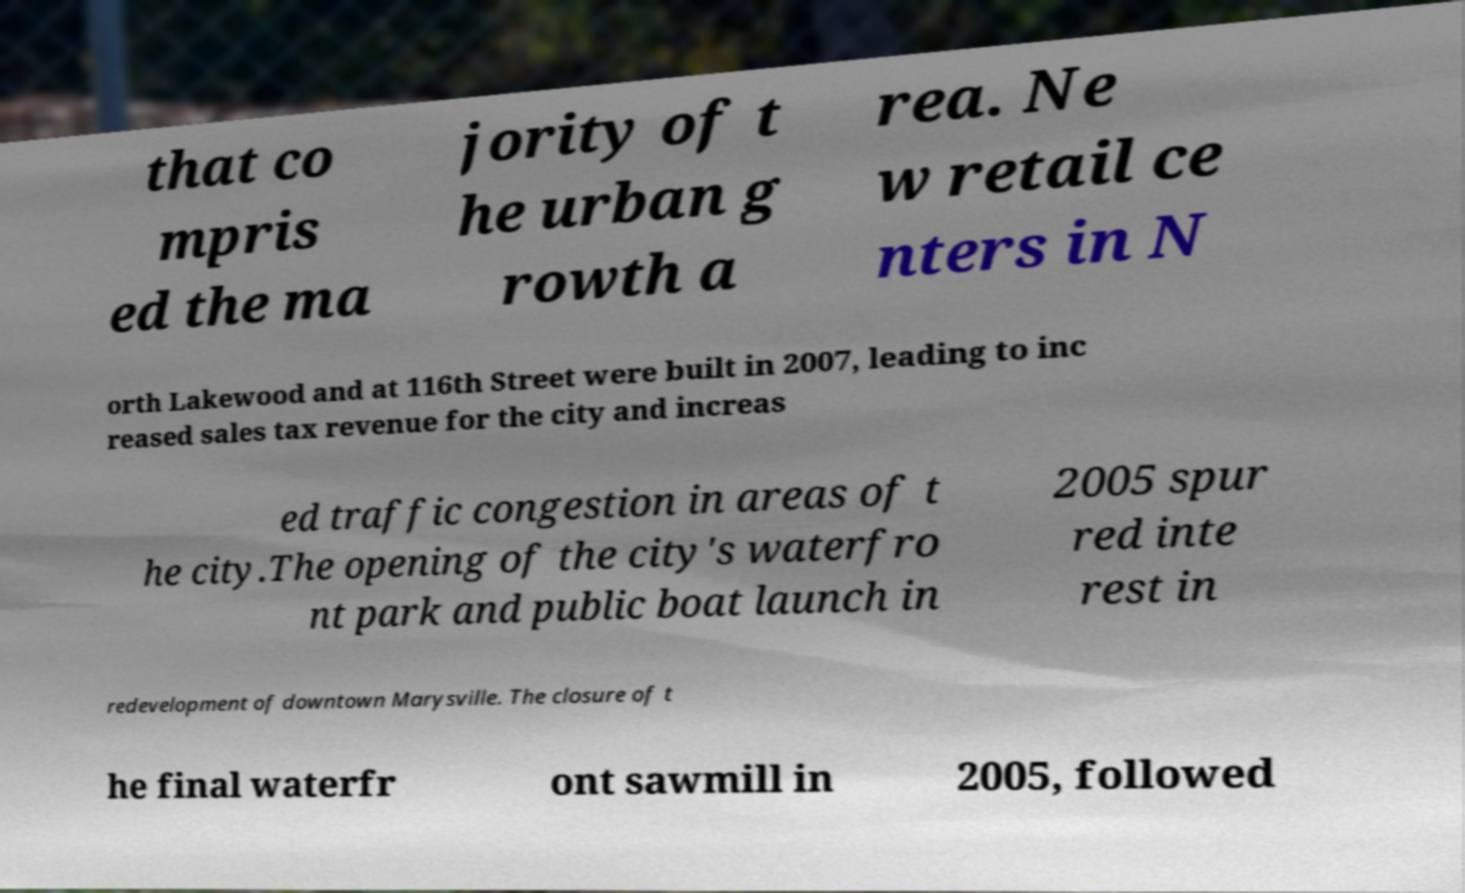What messages or text are displayed in this image? I need them in a readable, typed format. that co mpris ed the ma jority of t he urban g rowth a rea. Ne w retail ce nters in N orth Lakewood and at 116th Street were built in 2007, leading to inc reased sales tax revenue for the city and increas ed traffic congestion in areas of t he city.The opening of the city's waterfro nt park and public boat launch in 2005 spur red inte rest in redevelopment of downtown Marysville. The closure of t he final waterfr ont sawmill in 2005, followed 